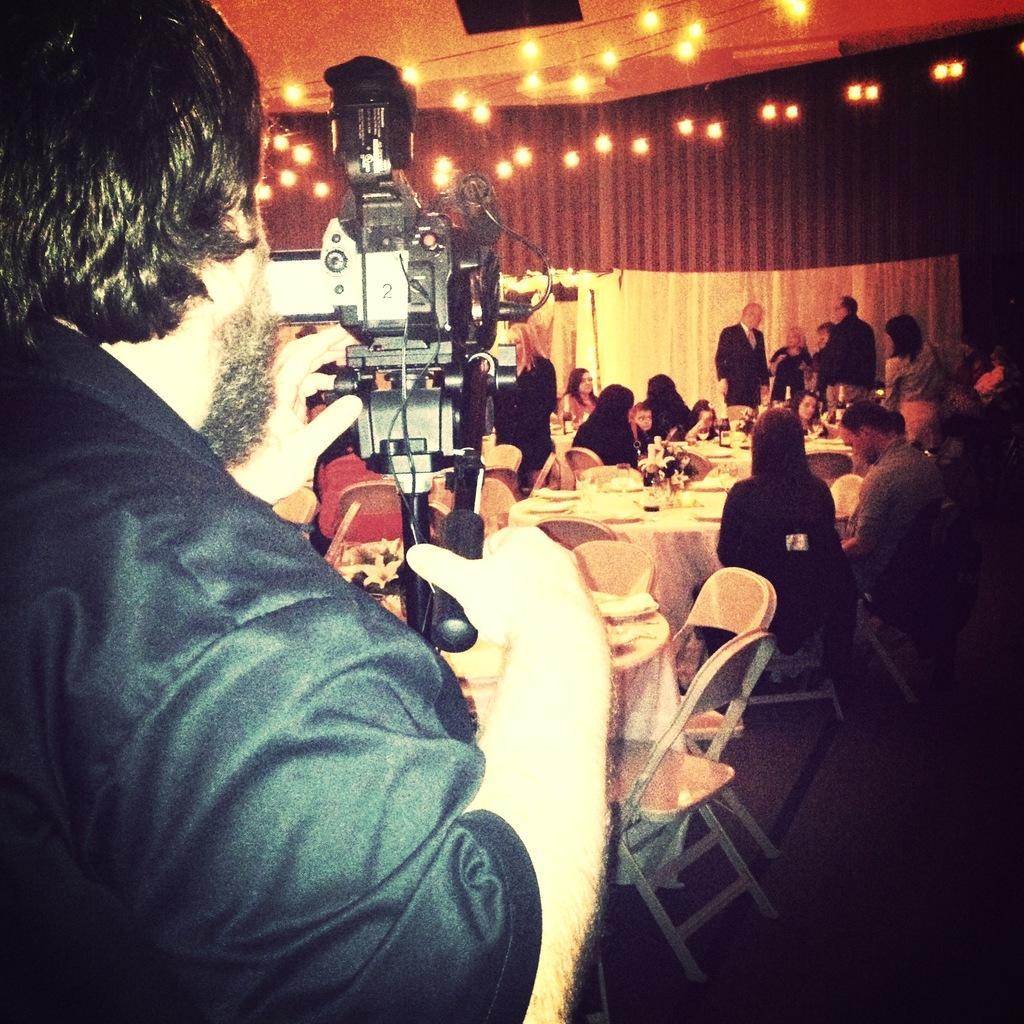Could you give a brief overview of what you see in this image? In the picture we can see some people are sitting on the chairs near the table on it, we can see some eatable items are placed, in the background, we can see some people are standing and talking near the curtain wall and one man is standing and capturing it with a camera. 